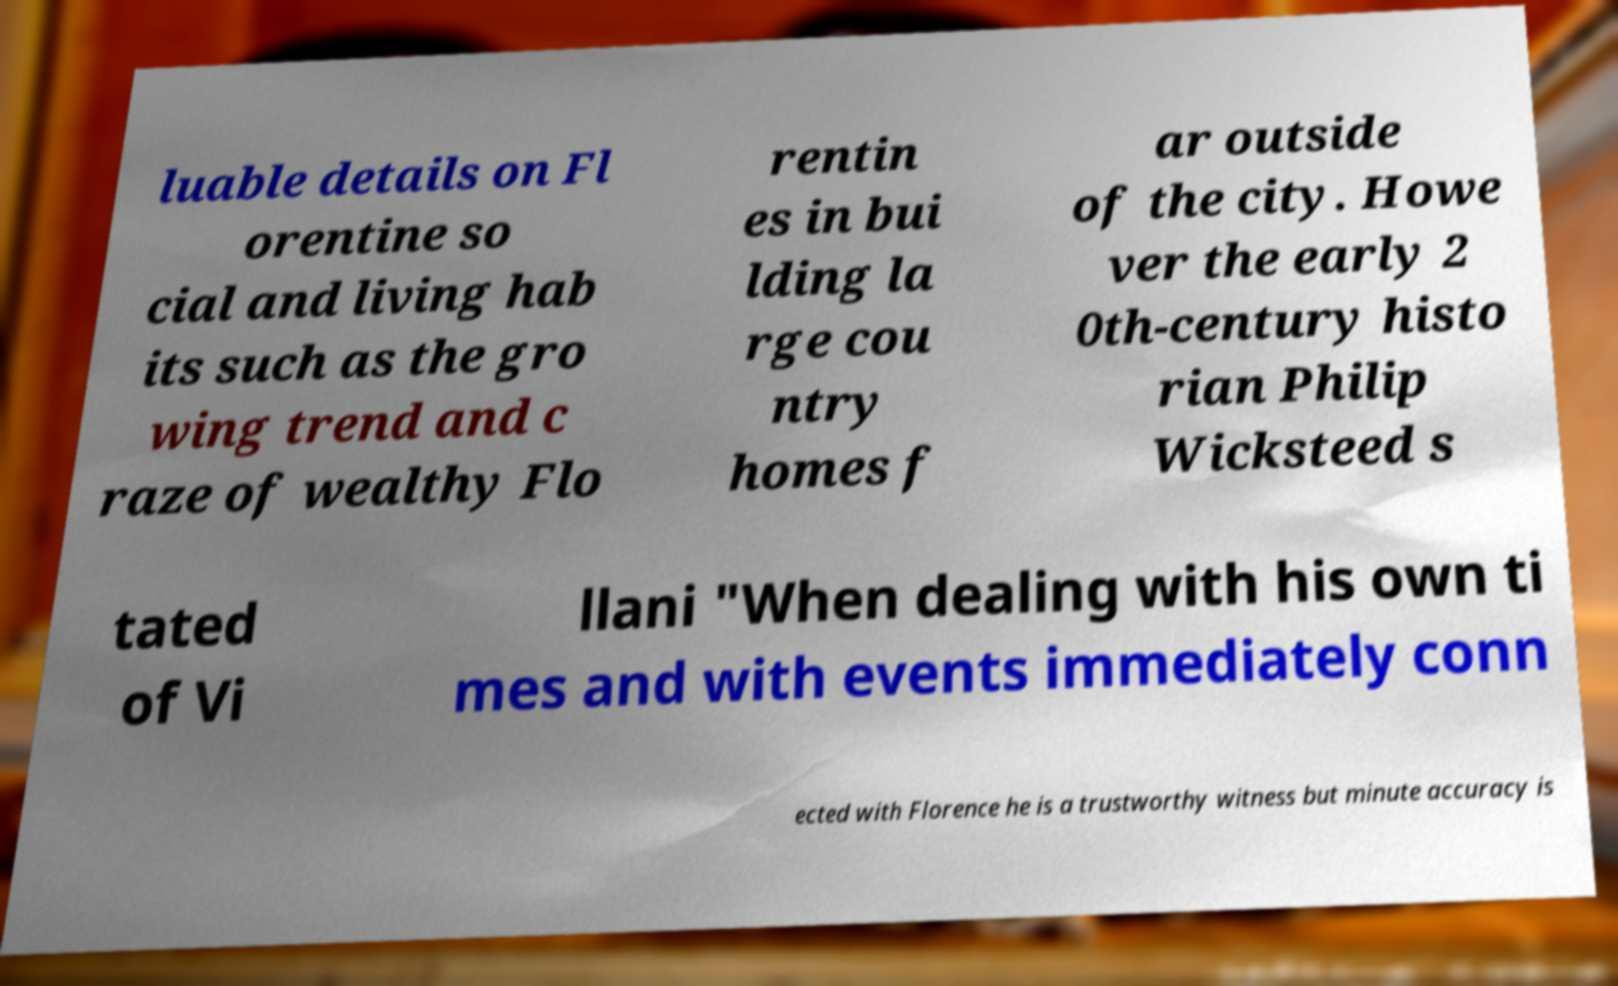What messages or text are displayed in this image? I need them in a readable, typed format. luable details on Fl orentine so cial and living hab its such as the gro wing trend and c raze of wealthy Flo rentin es in bui lding la rge cou ntry homes f ar outside of the city. Howe ver the early 2 0th-century histo rian Philip Wicksteed s tated of Vi llani "When dealing with his own ti mes and with events immediately conn ected with Florence he is a trustworthy witness but minute accuracy is 